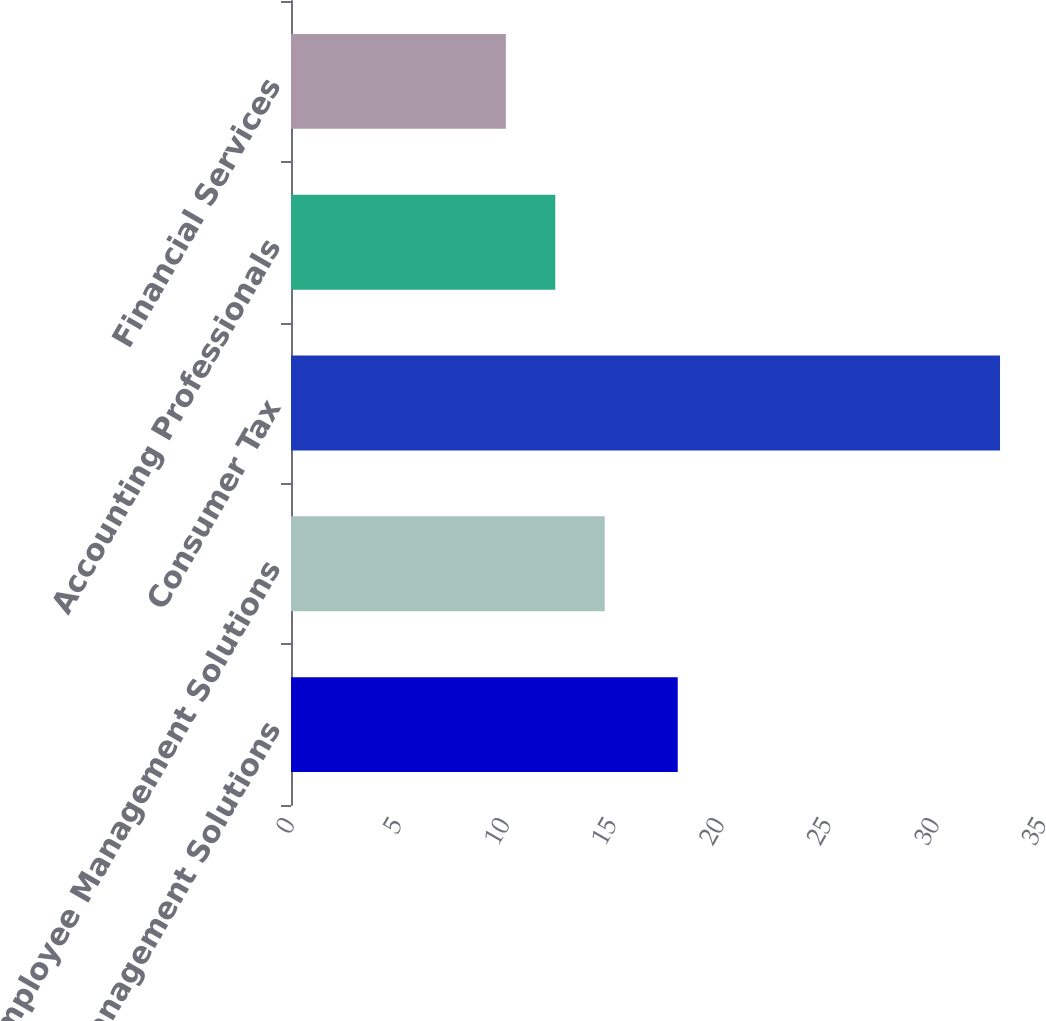Convert chart to OTSL. <chart><loc_0><loc_0><loc_500><loc_500><bar_chart><fcel>Financial Management Solutions<fcel>Employee Management Solutions<fcel>Consumer Tax<fcel>Accounting Professionals<fcel>Financial Services<nl><fcel>18<fcel>14.6<fcel>33<fcel>12.3<fcel>10<nl></chart> 